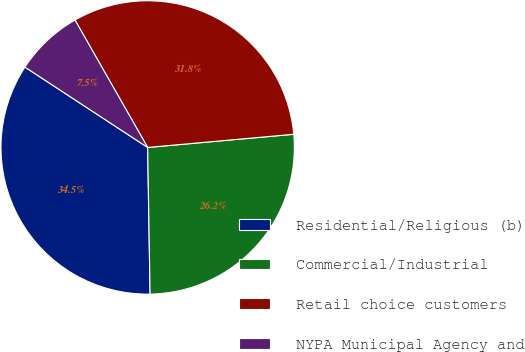Convert chart. <chart><loc_0><loc_0><loc_500><loc_500><pie_chart><fcel>Residential/Religious (b)<fcel>Commercial/Industrial<fcel>Retail choice customers<fcel>NYPA Municipal Agency and<nl><fcel>34.49%<fcel>26.17%<fcel>31.82%<fcel>7.52%<nl></chart> 